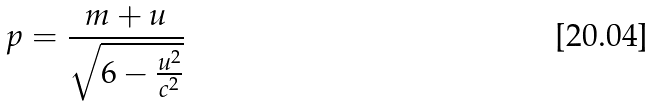Convert formula to latex. <formula><loc_0><loc_0><loc_500><loc_500>p = \frac { m + u } { \sqrt { 6 - \frac { u ^ { 2 } } { c ^ { 2 } } } }</formula> 